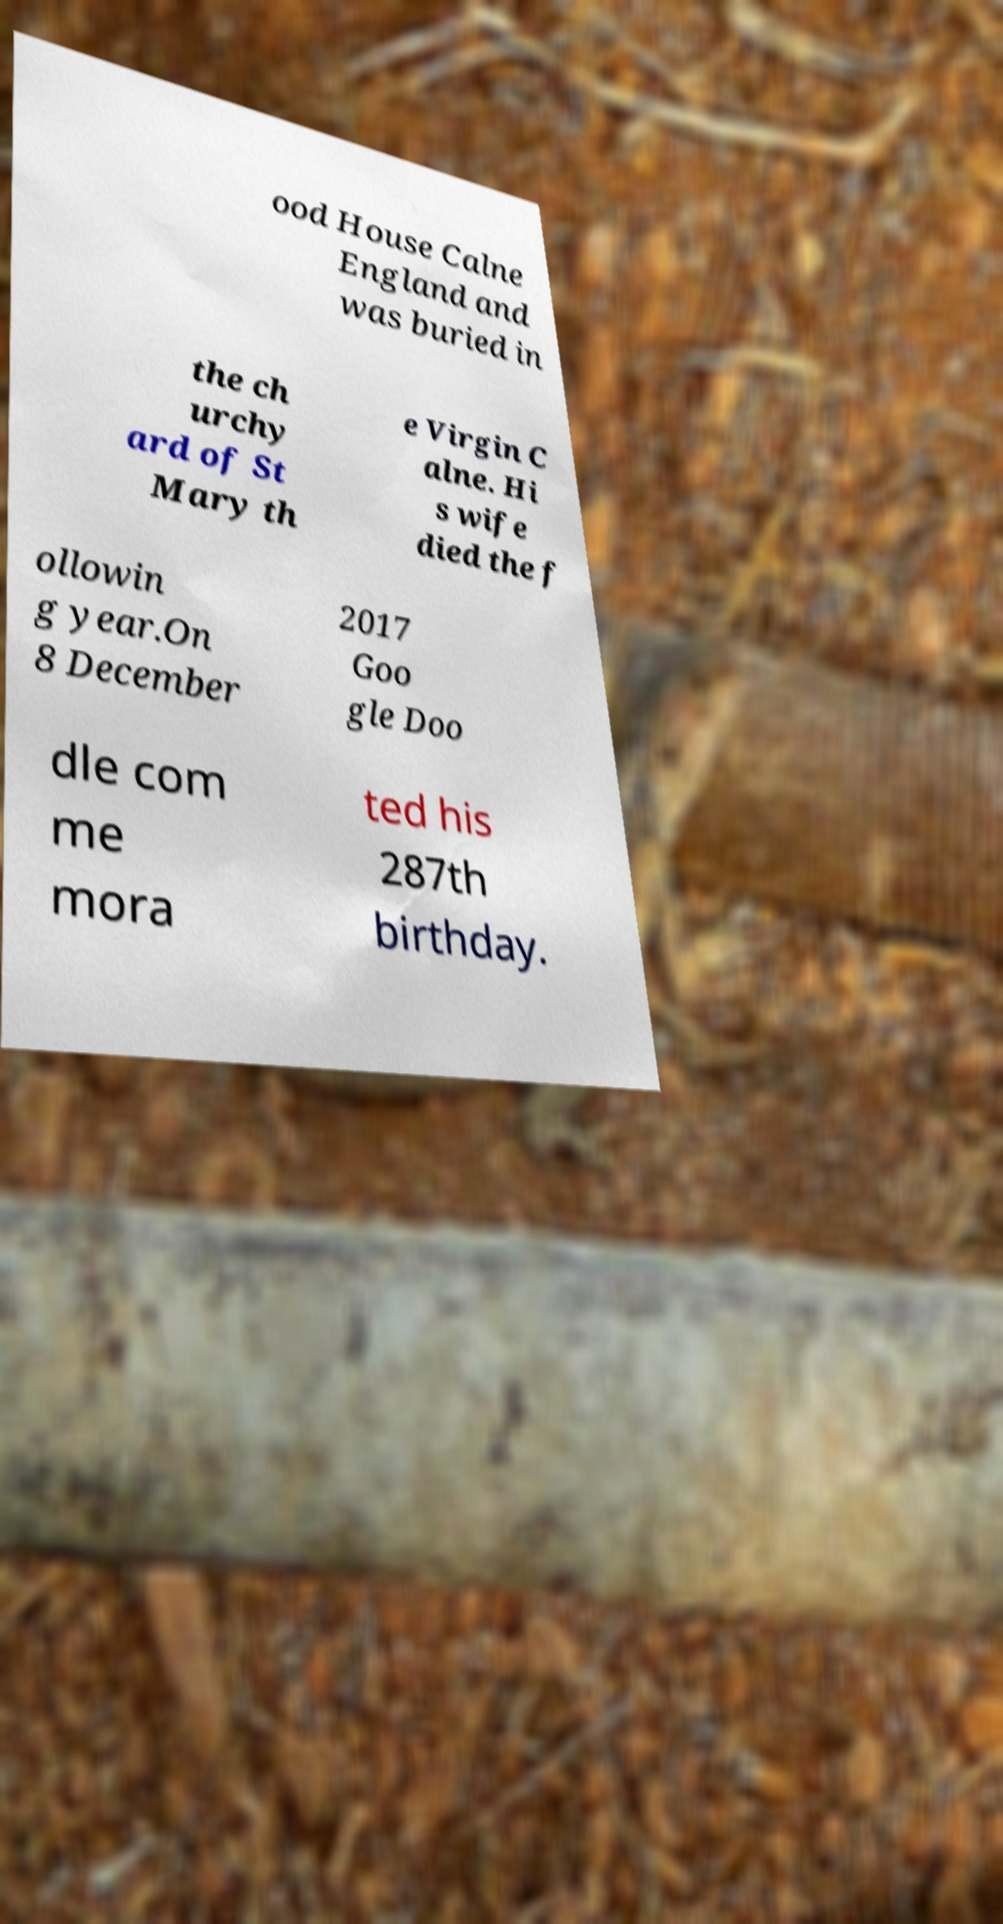Can you accurately transcribe the text from the provided image for me? ood House Calne England and was buried in the ch urchy ard of St Mary th e Virgin C alne. Hi s wife died the f ollowin g year.On 8 December 2017 Goo gle Doo dle com me mora ted his 287th birthday. 